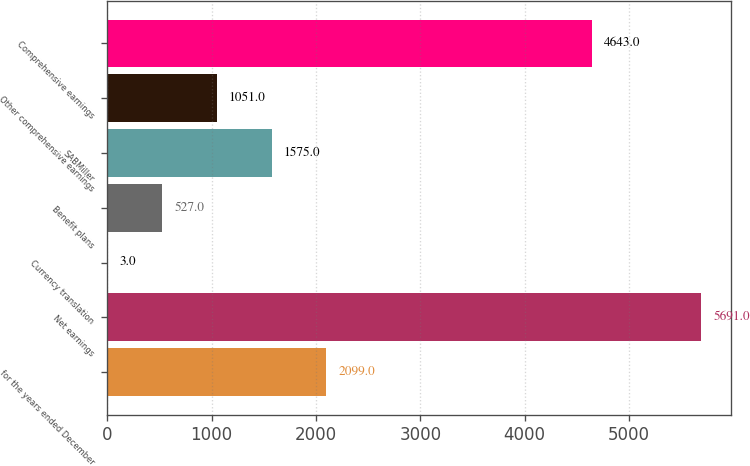Convert chart. <chart><loc_0><loc_0><loc_500><loc_500><bar_chart><fcel>for the years ended December<fcel>Net earnings<fcel>Currency translation<fcel>Benefit plans<fcel>SABMiller<fcel>Other comprehensive earnings<fcel>Comprehensive earnings<nl><fcel>2099<fcel>5691<fcel>3<fcel>527<fcel>1575<fcel>1051<fcel>4643<nl></chart> 